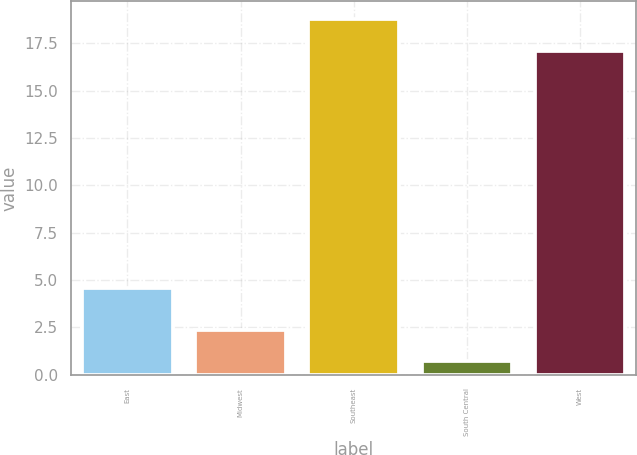Convert chart. <chart><loc_0><loc_0><loc_500><loc_500><bar_chart><fcel>East<fcel>Midwest<fcel>Southeast<fcel>South Central<fcel>West<nl><fcel>4.6<fcel>2.37<fcel>18.77<fcel>0.7<fcel>17.1<nl></chart> 